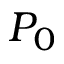<formula> <loc_0><loc_0><loc_500><loc_500>P _ { 0 }</formula> 